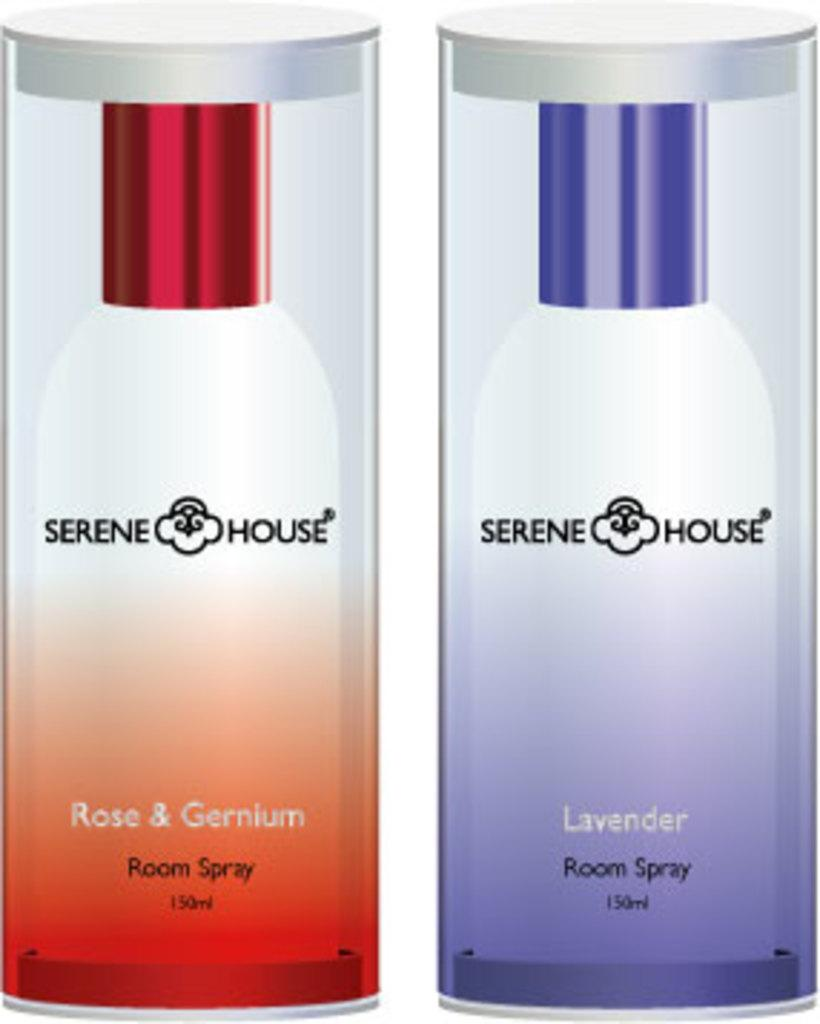<image>
Summarize the visual content of the image. Two containers of room spray by Serene House. 